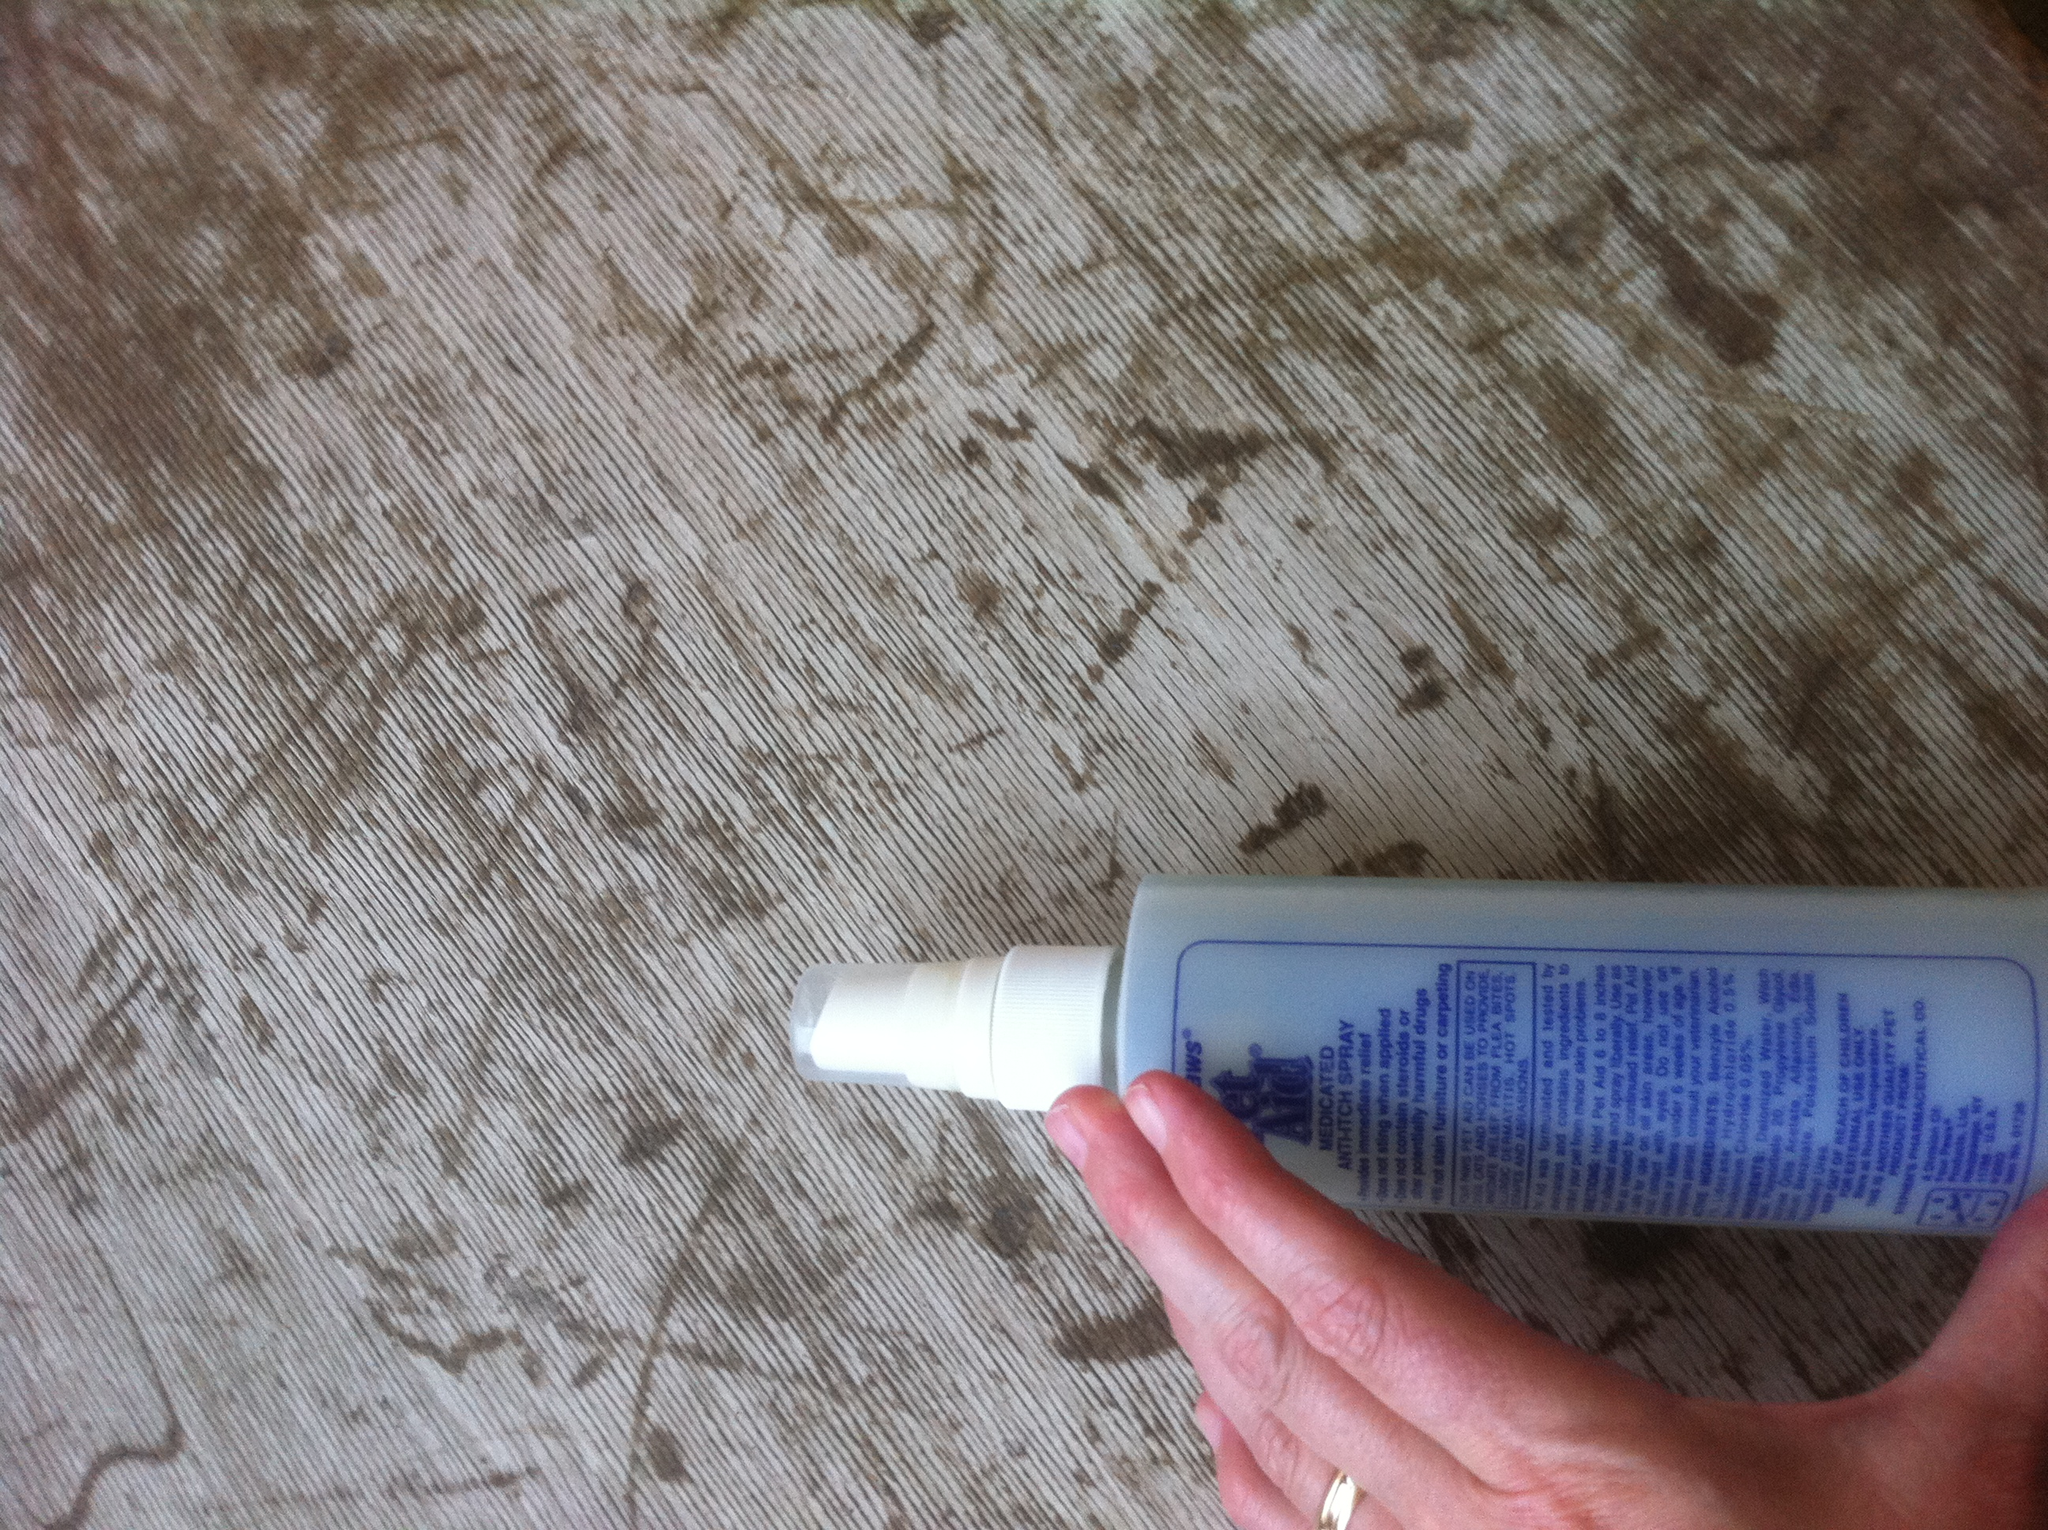How do you apply this product to a dog's coat? To apply this product to your dog's coat, make sure to hold the bottle a few inches away from the affected area and spray evenly. Gently massage it into the skin to ensure good coverage. Always follow the instructions on the label for the best results and avoid spraying near the dog's eyes, ears, or nose. 